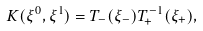Convert formula to latex. <formula><loc_0><loc_0><loc_500><loc_500>K ( \xi ^ { 0 } , \xi ^ { 1 } ) = T _ { - } ( \xi _ { - } ) T _ { + } ^ { - 1 } ( \xi _ { + } ) ,</formula> 